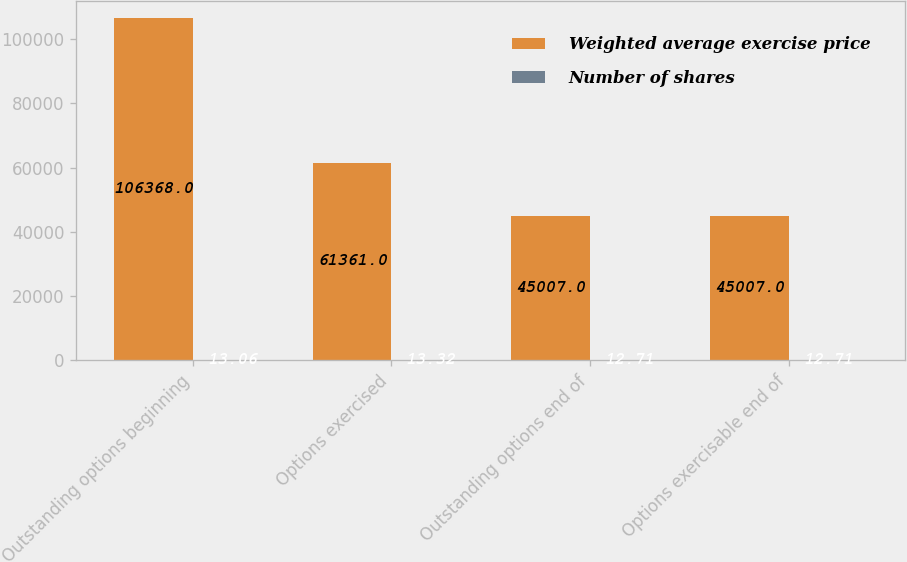Convert chart to OTSL. <chart><loc_0><loc_0><loc_500><loc_500><stacked_bar_chart><ecel><fcel>Outstanding options beginning<fcel>Options exercised<fcel>Outstanding options end of<fcel>Options exercisable end of<nl><fcel>Weighted average exercise price<fcel>106368<fcel>61361<fcel>45007<fcel>45007<nl><fcel>Number of shares<fcel>13.06<fcel>13.32<fcel>12.71<fcel>12.71<nl></chart> 